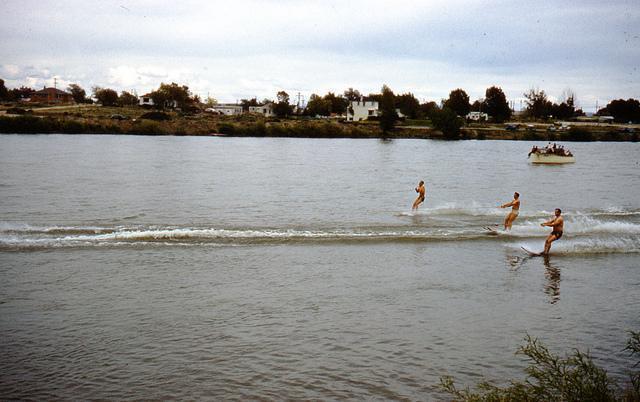Why are the men reaching forward while on skis?
Choose the right answer from the provided options to respond to the question.
Options: To swim, to wave, waterskiing, to dance. Waterskiing. 